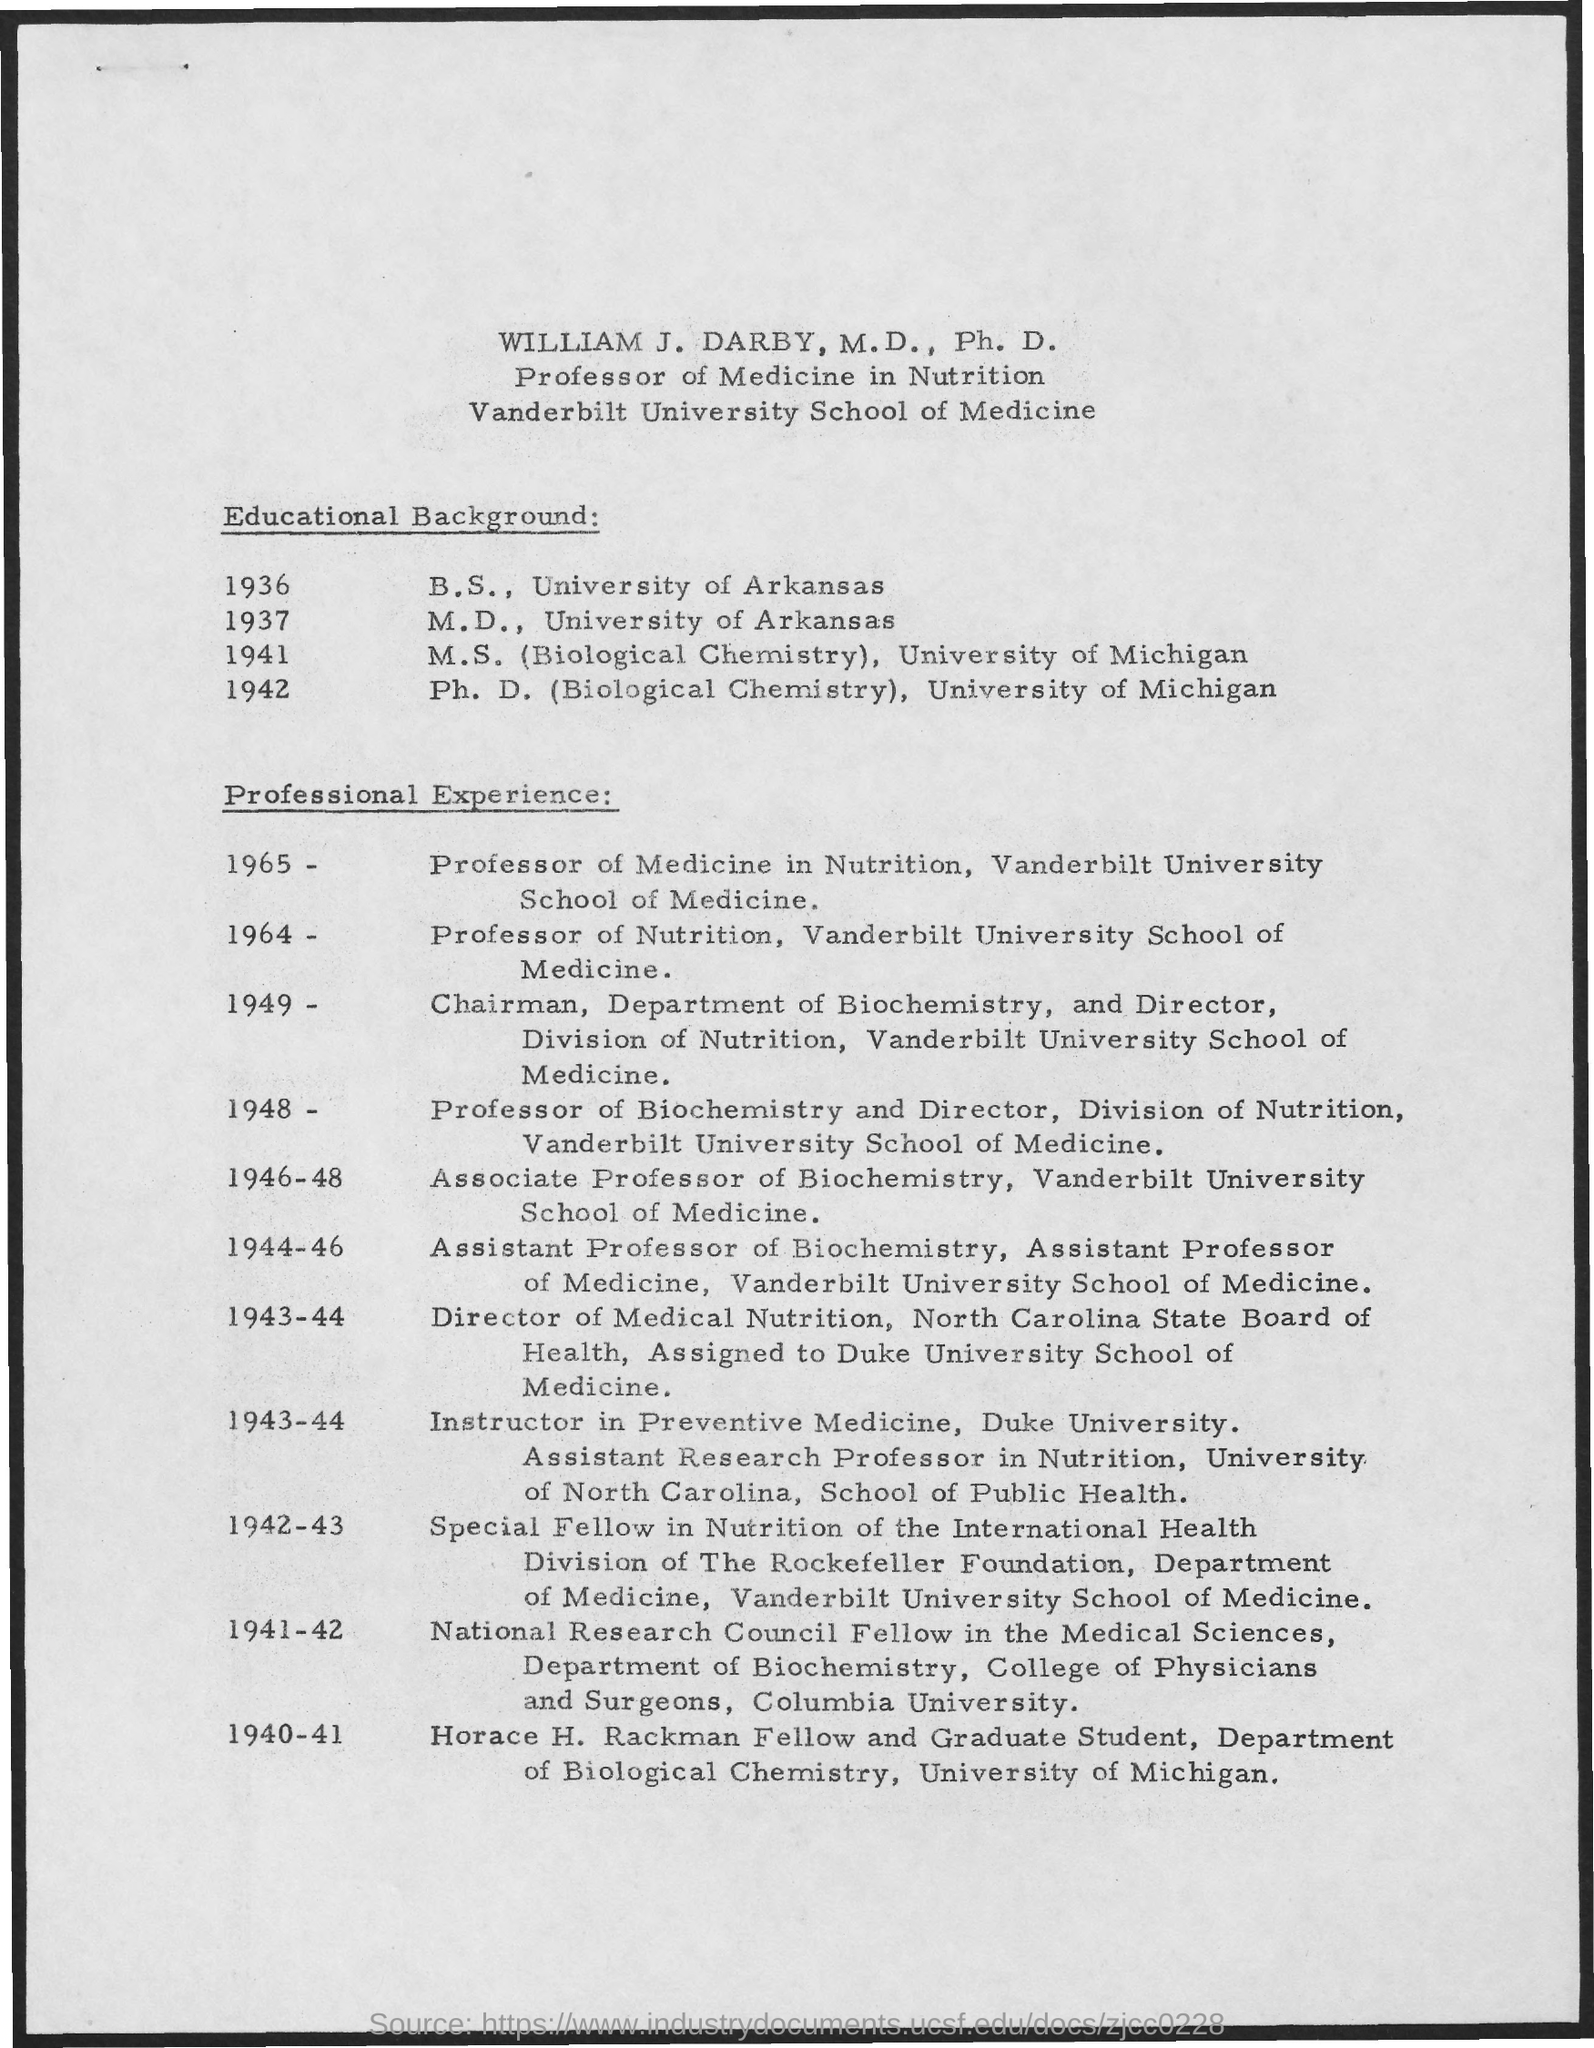List a handful of essential elements in this visual. William J. Darby, M.D., Ph.D., completed his Ph.D. in Biological Chemistry at the University of Michigan. William J. Darby, M.D., Ph.D. completed his M.D. degree at the University of Arkansas in 1937. William J. Darby, M.D., Ph.D., is a Professor of Medicine in Nutrition. WILLIAM J. DARBY, M.D., Ph.D. completed his B.S. in the University of Arkansas in 1936. 